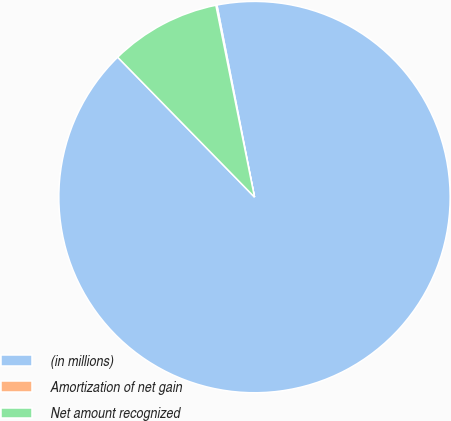Convert chart to OTSL. <chart><loc_0><loc_0><loc_500><loc_500><pie_chart><fcel>(in millions)<fcel>Amortization of net gain<fcel>Net amount recognized<nl><fcel>90.75%<fcel>0.09%<fcel>9.16%<nl></chart> 